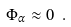Convert formula to latex. <formula><loc_0><loc_0><loc_500><loc_500>\Phi _ { \alpha } \approx 0 \ .</formula> 